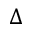<formula> <loc_0><loc_0><loc_500><loc_500>\Delta</formula> 